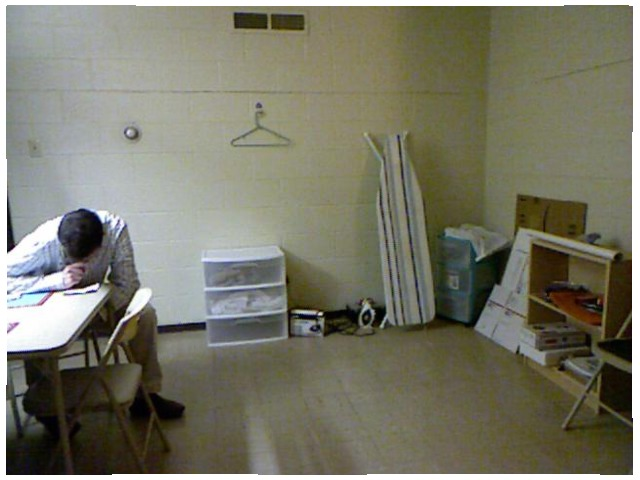<image>
Is the iron board on the floor? Yes. Looking at the image, I can see the iron board is positioned on top of the floor, with the floor providing support. Where is the wall in relation to the man? Is it under the man? No. The wall is not positioned under the man. The vertical relationship between these objects is different. 